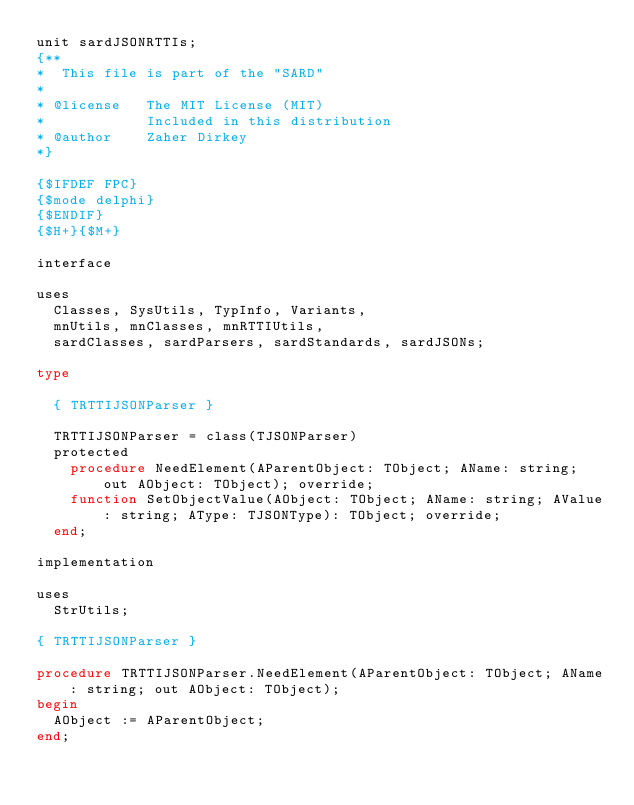<code> <loc_0><loc_0><loc_500><loc_500><_Pascal_>unit sardJSONRTTIs;
{**
*  This file is part of the "SARD"
*
* @license   The MIT License (MIT)
*            Included in this distribution
* @author    Zaher Dirkey 
*}

{$IFDEF FPC}
{$mode delphi}
{$ENDIF}
{$H+}{$M+}

interface

uses
  Classes, SysUtils, TypInfo, Variants,
  mnUtils, mnClasses, mnRTTIUtils,
  sardClasses, sardParsers, sardStandards, sardJSONs;

type

  { TRTTIJSONParser }

  TRTTIJSONParser = class(TJSONParser)
  protected
    procedure NeedElement(AParentObject: TObject; AName: string; out AObject: TObject); override;
    function SetObjectValue(AObject: TObject; AName: string; AValue: string; AType: TJSONType): TObject; override;
  end;

implementation

uses
  StrUtils;

{ TRTTIJSONParser }

procedure TRTTIJSONParser.NeedElement(AParentObject: TObject; AName: string; out AObject: TObject);
begin
  AObject := AParentObject;
end;
</code> 